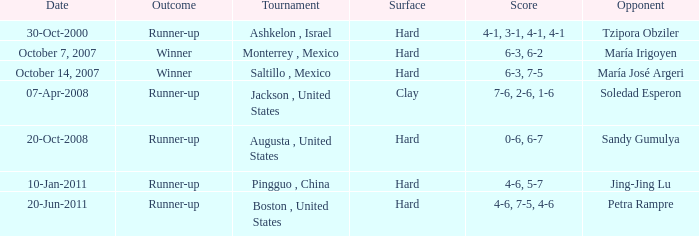Parse the table in full. {'header': ['Date', 'Outcome', 'Tournament', 'Surface', 'Score', 'Opponent'], 'rows': [['30-Oct-2000', 'Runner-up', 'Ashkelon , Israel', 'Hard', '4-1, 3-1, 4-1, 4-1', 'Tzipora Obziler'], ['October 7, 2007', 'Winner', 'Monterrey , Mexico', 'Hard', '6-3, 6-2', 'María Irigoyen'], ['October 14, 2007', 'Winner', 'Saltillo , Mexico', 'Hard', '6-3, 7-5', 'María José Argeri'], ['07-Apr-2008', 'Runner-up', 'Jackson , United States', 'Clay', '7-6, 2-6, 1-6', 'Soledad Esperon'], ['20-Oct-2008', 'Runner-up', 'Augusta , United States', 'Hard', '0-6, 6-7', 'Sandy Gumulya'], ['10-Jan-2011', 'Runner-up', 'Pingguo , China', 'Hard', '4-6, 5-7', 'Jing-Jing Lu'], ['20-Jun-2011', 'Runner-up', 'Boston , United States', 'Hard', '4-6, 7-5, 4-6', 'Petra Rampre']]} Which tournament was held on October 14, 2007? Saltillo , Mexico. 